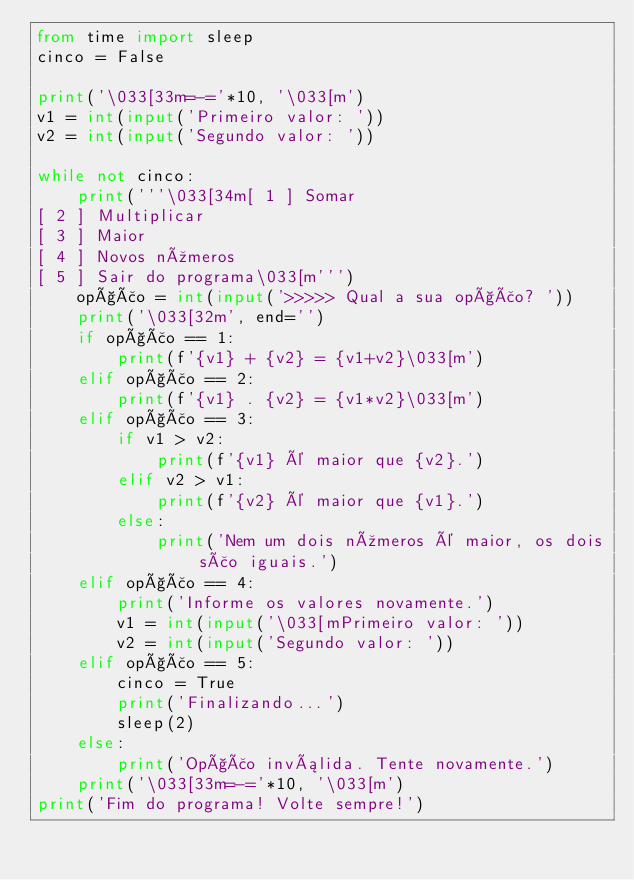<code> <loc_0><loc_0><loc_500><loc_500><_Python_>from time import sleep
cinco = False

print('\033[33m=-='*10, '\033[m')
v1 = int(input('Primeiro valor: '))
v2 = int(input('Segundo valor: '))

while not cinco:
    print('''\033[34m[ 1 ] Somar
[ 2 ] Multiplicar
[ 3 ] Maior
[ 4 ] Novos números
[ 5 ] Sair do programa\033[m''')
    opção = int(input('>>>>> Qual a sua opção? '))
    print('\033[32m', end='')
    if opção == 1:
        print(f'{v1} + {v2} = {v1+v2}\033[m')
    elif opção == 2:
        print(f'{v1} . {v2} = {v1*v2}\033[m')
    elif opção == 3:
        if v1 > v2:
            print(f'{v1} é maior que {v2}.')
        elif v2 > v1:
            print(f'{v2} é maior que {v1}.')
        else:
            print('Nem um dois números é maior, os dois são iguais.')
    elif opção == 4:
        print('Informe os valores novamente.')
        v1 = int(input('\033[mPrimeiro valor: '))
        v2 = int(input('Segundo valor: '))
    elif opção == 5:
        cinco = True
        print('Finalizando...')
        sleep(2)
    else:
        print('Opção inválida. Tente novamente.')
    print('\033[33m=-='*10, '\033[m')
print('Fim do programa! Volte sempre!')
</code> 